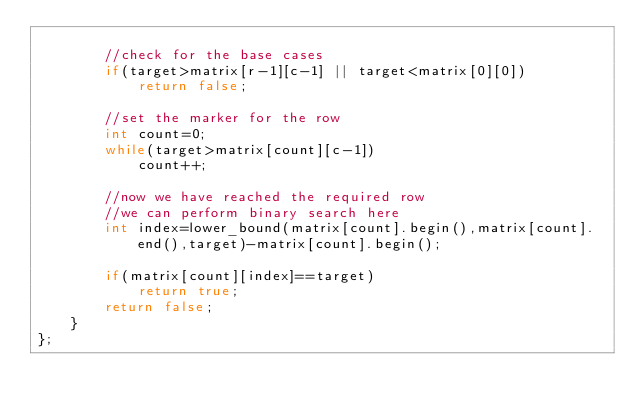<code> <loc_0><loc_0><loc_500><loc_500><_C++_>
        //check for the base cases
        if(target>matrix[r-1][c-1] || target<matrix[0][0])
            return false;

        //set the marker for the row
        int count=0;
        while(target>matrix[count][c-1])
            count++;

        //now we have reached the required row
        //we can perform binary search here
        int index=lower_bound(matrix[count].begin(),matrix[count].end(),target)-matrix[count].begin();

        if(matrix[count][index]==target)
            return true;
        return false;
    }
};
</code> 